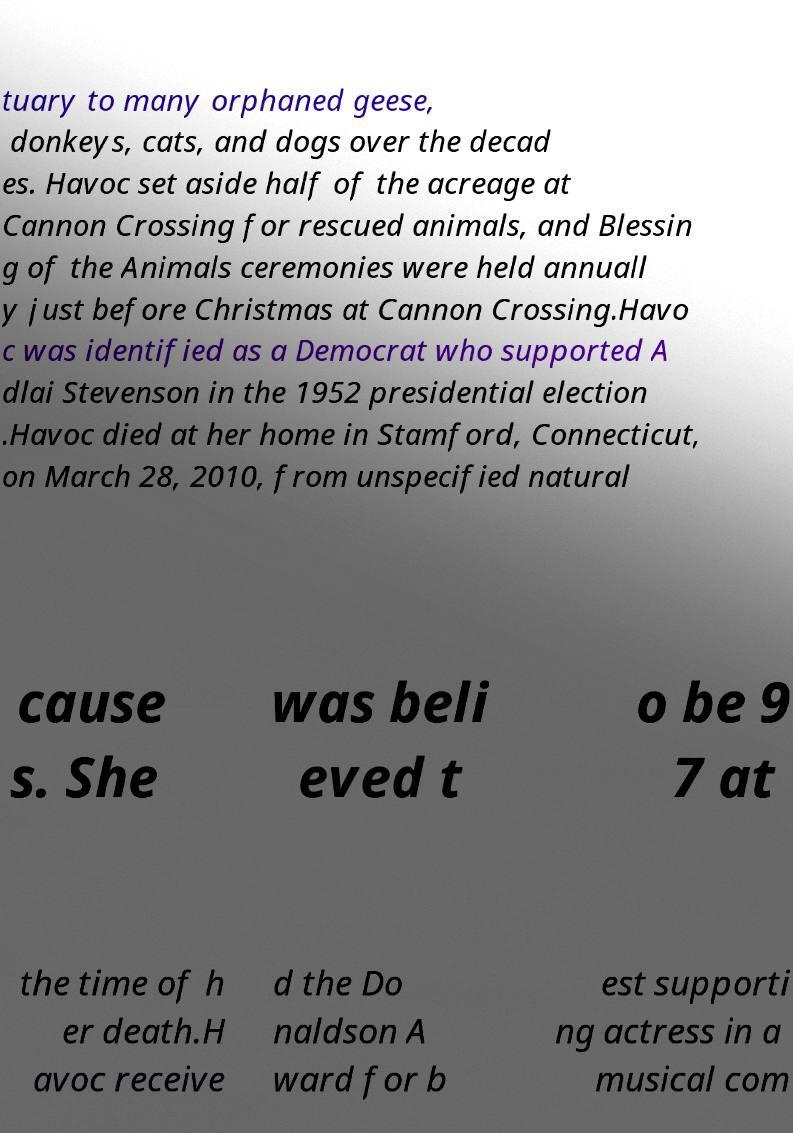What messages or text are displayed in this image? I need them in a readable, typed format. tuary to many orphaned geese, donkeys, cats, and dogs over the decad es. Havoc set aside half of the acreage at Cannon Crossing for rescued animals, and Blessin g of the Animals ceremonies were held annuall y just before Christmas at Cannon Crossing.Havo c was identified as a Democrat who supported A dlai Stevenson in the 1952 presidential election .Havoc died at her home in Stamford, Connecticut, on March 28, 2010, from unspecified natural cause s. She was beli eved t o be 9 7 at the time of h er death.H avoc receive d the Do naldson A ward for b est supporti ng actress in a musical com 